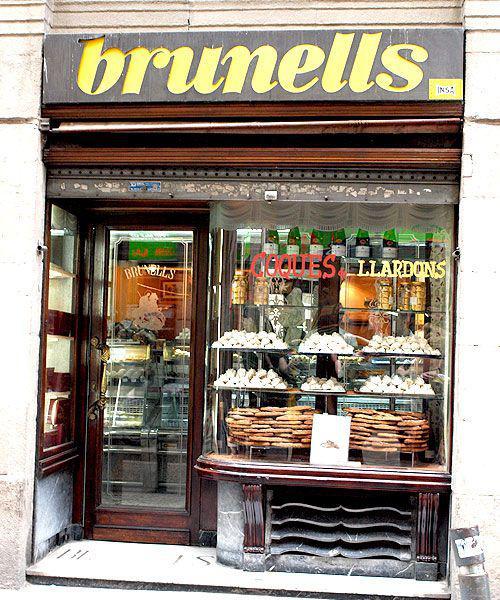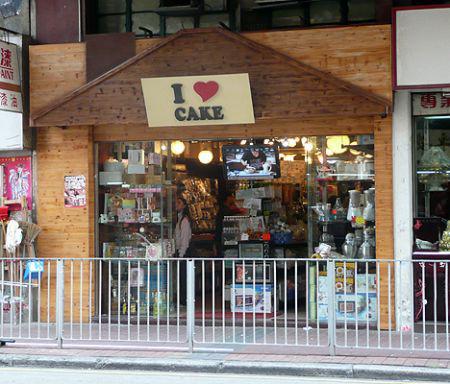The first image is the image on the left, the second image is the image on the right. For the images shown, is this caption "One of the shops has tables and chairs out front." true? Answer yes or no. No. 